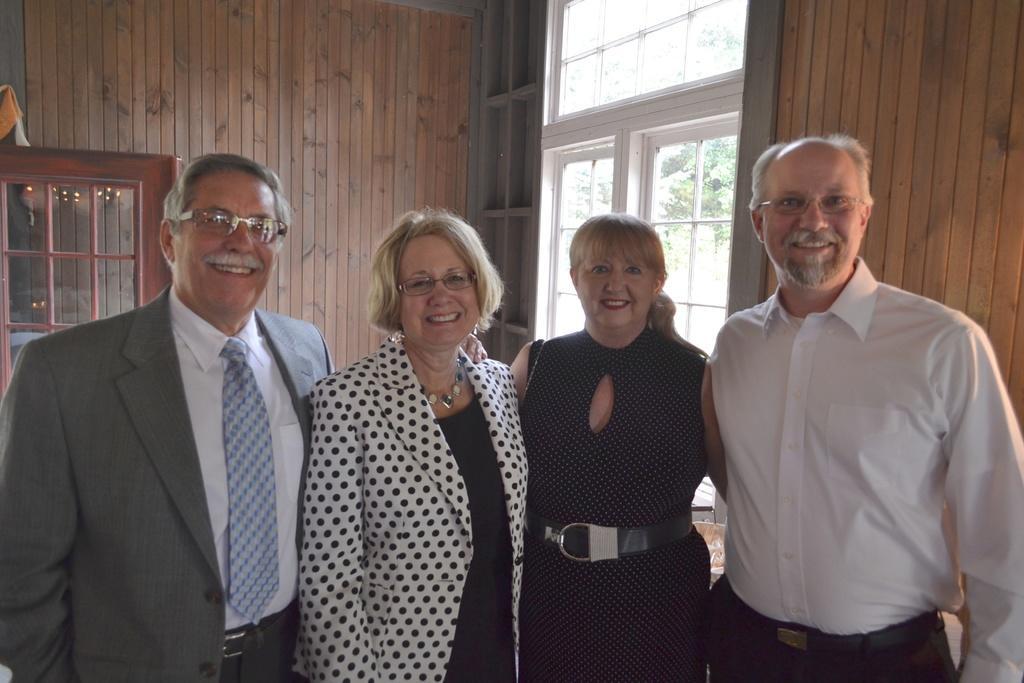Describe this image in one or two sentences. In this picture we can see group of people, they are all smiling, and few people wore spectacles, in the background we can see few windows and trees. 